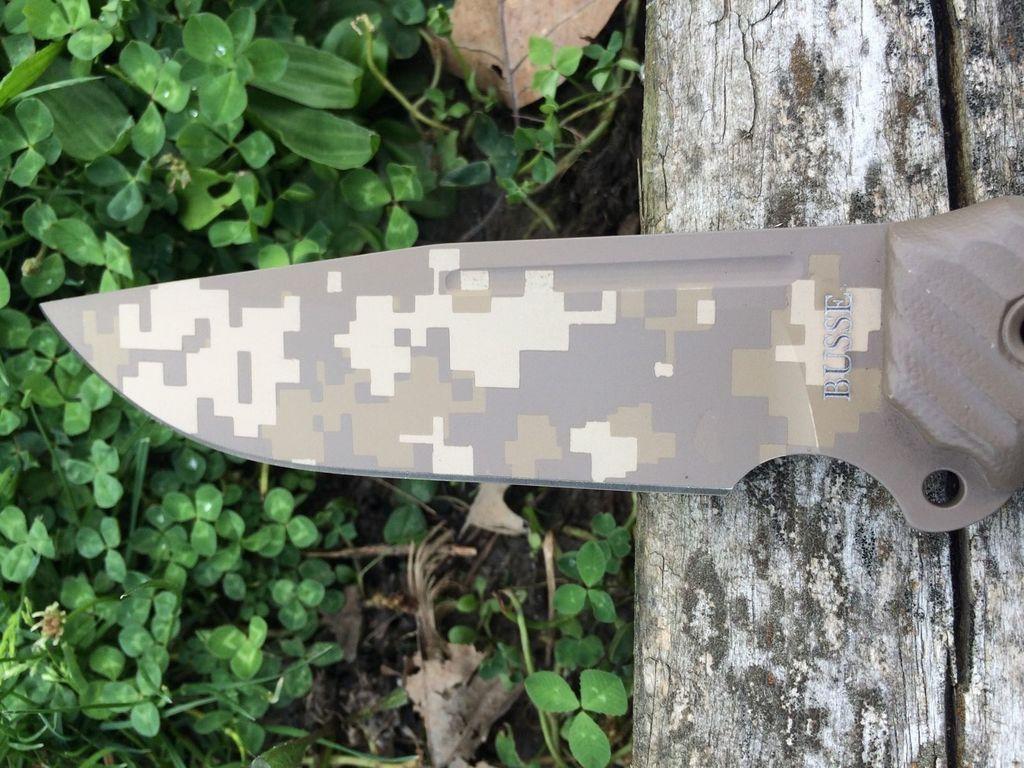Can you describe this image briefly? In this image we can see knife placed on the surface. In the background, we can see group of leaves. 